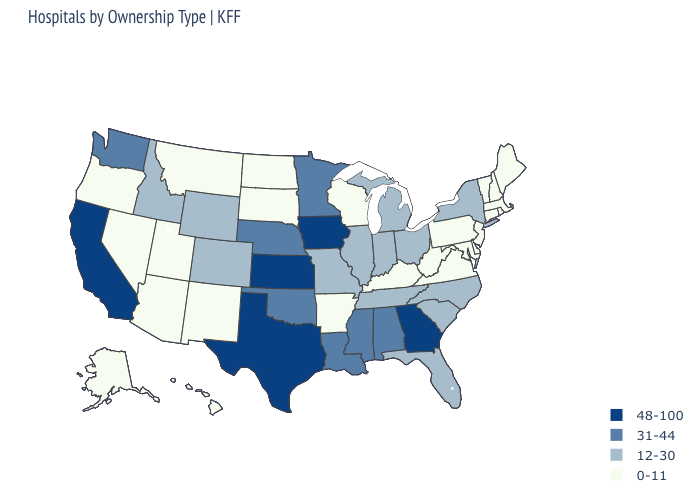Does Washington have the lowest value in the West?
Answer briefly. No. Among the states that border Connecticut , which have the lowest value?
Short answer required. Massachusetts, Rhode Island. Name the states that have a value in the range 31-44?
Quick response, please. Alabama, Louisiana, Minnesota, Mississippi, Nebraska, Oklahoma, Washington. What is the value of Wisconsin?
Be succinct. 0-11. What is the lowest value in the Northeast?
Give a very brief answer. 0-11. Which states have the highest value in the USA?
Give a very brief answer. California, Georgia, Iowa, Kansas, Texas. Name the states that have a value in the range 0-11?
Quick response, please. Alaska, Arizona, Arkansas, Connecticut, Delaware, Hawaii, Kentucky, Maine, Maryland, Massachusetts, Montana, Nevada, New Hampshire, New Jersey, New Mexico, North Dakota, Oregon, Pennsylvania, Rhode Island, South Dakota, Utah, Vermont, Virginia, West Virginia, Wisconsin. Does Rhode Island have the lowest value in the USA?
Concise answer only. Yes. Which states have the lowest value in the West?
Quick response, please. Alaska, Arizona, Hawaii, Montana, Nevada, New Mexico, Oregon, Utah. Name the states that have a value in the range 48-100?
Answer briefly. California, Georgia, Iowa, Kansas, Texas. What is the value of New Mexico?
Give a very brief answer. 0-11. Name the states that have a value in the range 48-100?
Quick response, please. California, Georgia, Iowa, Kansas, Texas. Which states hav the highest value in the West?
Quick response, please. California. How many symbols are there in the legend?
Answer briefly. 4. Is the legend a continuous bar?
Give a very brief answer. No. 